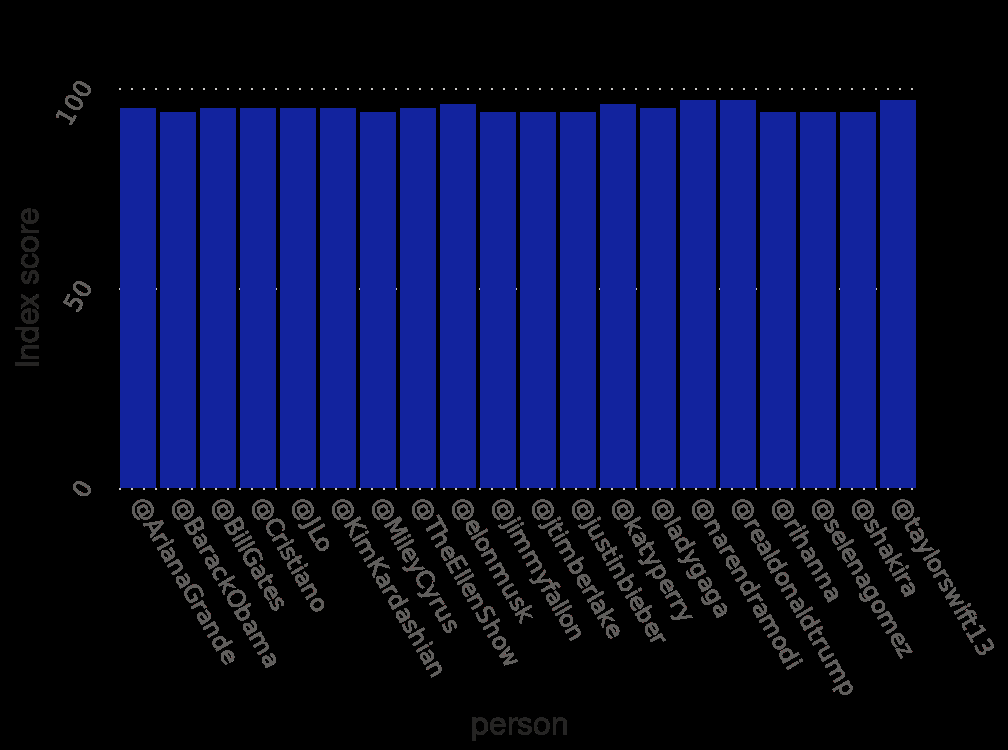<image>
Were there any influencers on Twitter with significantly higher scores? No, only some scoring slightly higher scores. Did all the influencers on Twitter get the same score?  No, only some scoring slightly higher scores. Offer a thorough analysis of the image. many of the influencers on twitter shared a similar score, only some scoring slightly higher scores. What does the y-axis measure? The y-axis measures the "Index score". 